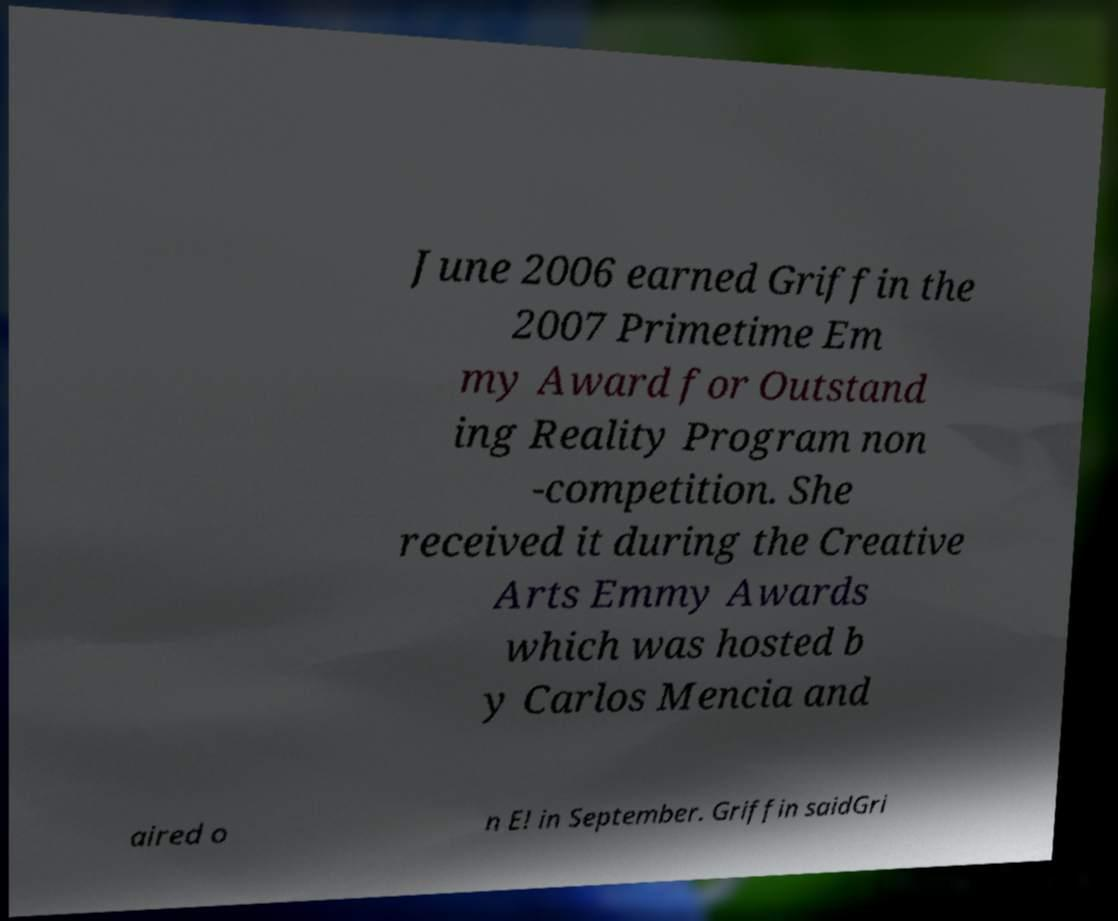I need the written content from this picture converted into text. Can you do that? June 2006 earned Griffin the 2007 Primetime Em my Award for Outstand ing Reality Program non -competition. She received it during the Creative Arts Emmy Awards which was hosted b y Carlos Mencia and aired o n E! in September. Griffin saidGri 